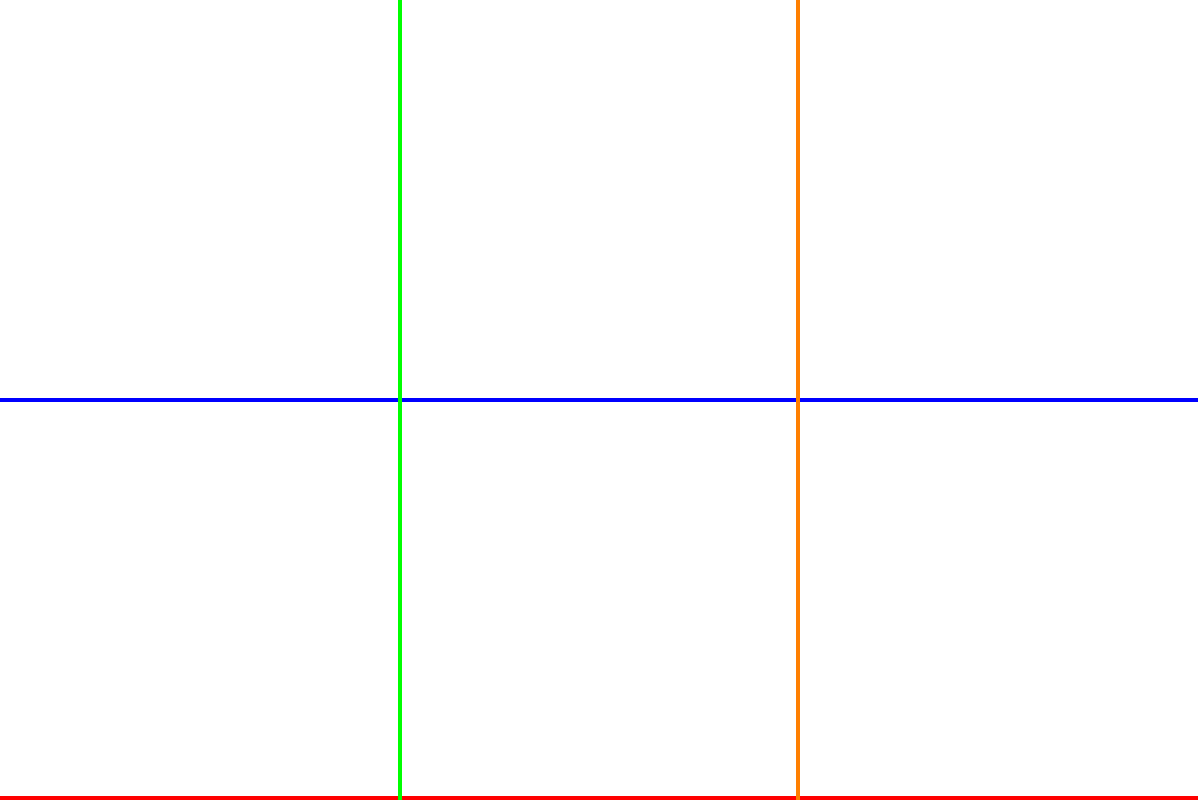As a tour guide, you're explaining the subway system to visitors. If a tourist wants to go from Central Station to the Airport, what is the minimum number of line changes required? To determine the minimum number of line changes required to travel from Central Station to the Airport, let's analyze the subway map step-by-step:

1. Identify the starting point: Central Station is located on the Red Line (bottom horizontal line).
2. Identify the destination: The Airport is on the Blue Line (second horizontal line from the bottom).
3. Trace possible routes:
   a. From Central Station, we can travel along the Red Line to the right.
   b. We need to change to the Blue Line to reach the Airport.
   c. There are two possible transfer points: the intersection of Red and Green lines, or the intersection of Red and Orange lines.
4. Count the line changes:
   a. Option 1: Red Line → Green Line → Blue Line (2 changes)
   b. Option 2: Red Line → Orange Line → Blue Line (2 changes)
5. Evaluate the options:
   Both routes require 2 line changes, which is the minimum number possible given the layout of the subway system.

Therefore, the minimum number of line changes required to go from Central Station to the Airport is 1.
Answer: 1 